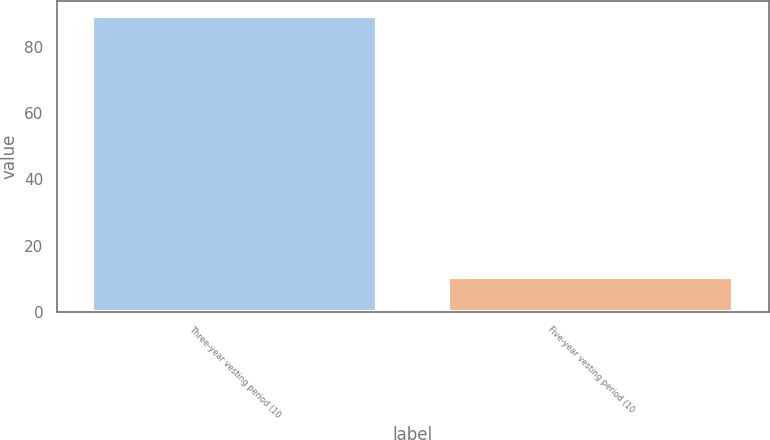Convert chart. <chart><loc_0><loc_0><loc_500><loc_500><bar_chart><fcel>Three-year vesting period (10<fcel>Five-year vesting period (10<nl><fcel>89.5<fcel>10.5<nl></chart> 